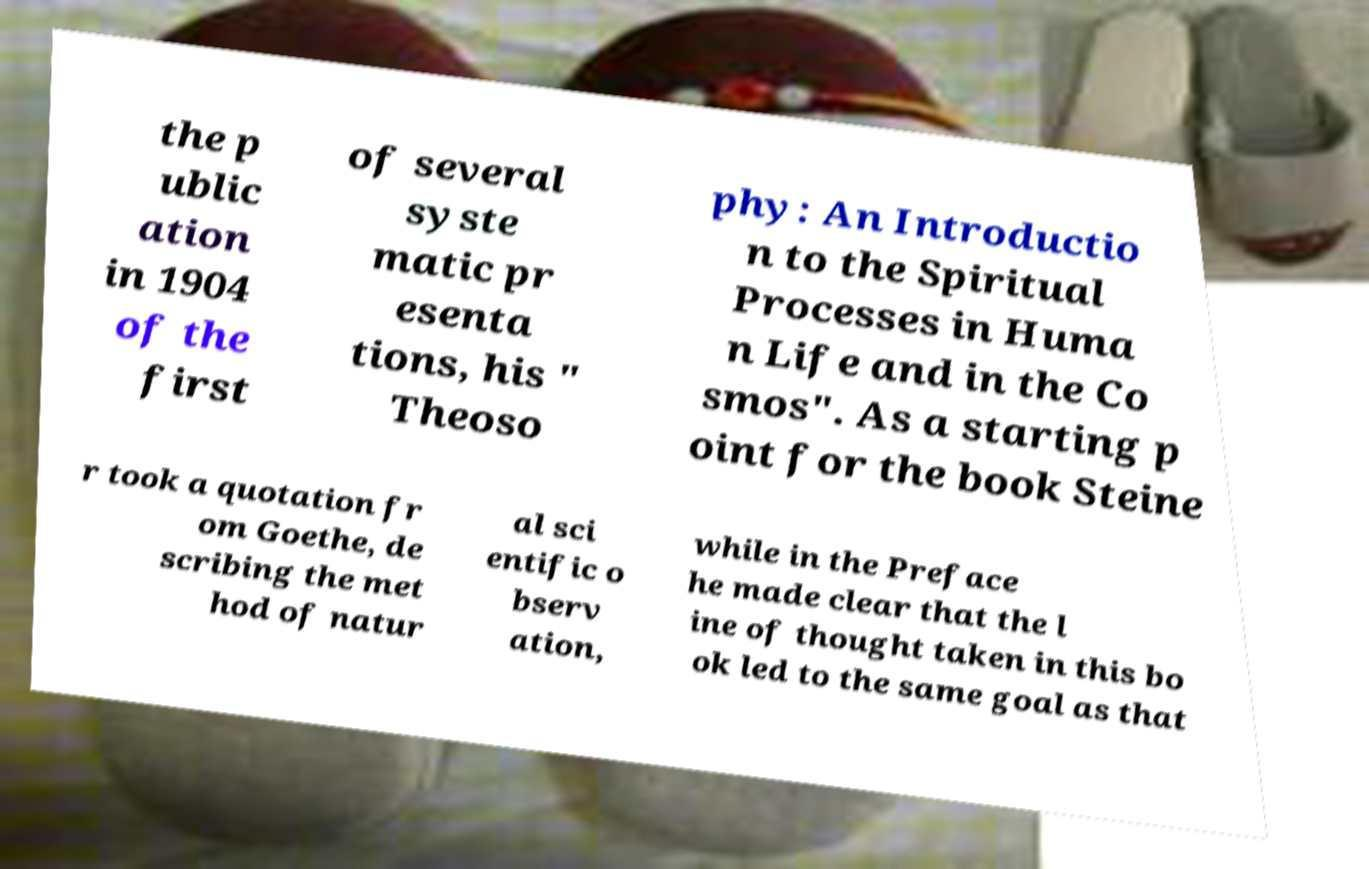I need the written content from this picture converted into text. Can you do that? the p ublic ation in 1904 of the first of several syste matic pr esenta tions, his " Theoso phy: An Introductio n to the Spiritual Processes in Huma n Life and in the Co smos". As a starting p oint for the book Steine r took a quotation fr om Goethe, de scribing the met hod of natur al sci entific o bserv ation, while in the Preface he made clear that the l ine of thought taken in this bo ok led to the same goal as that 